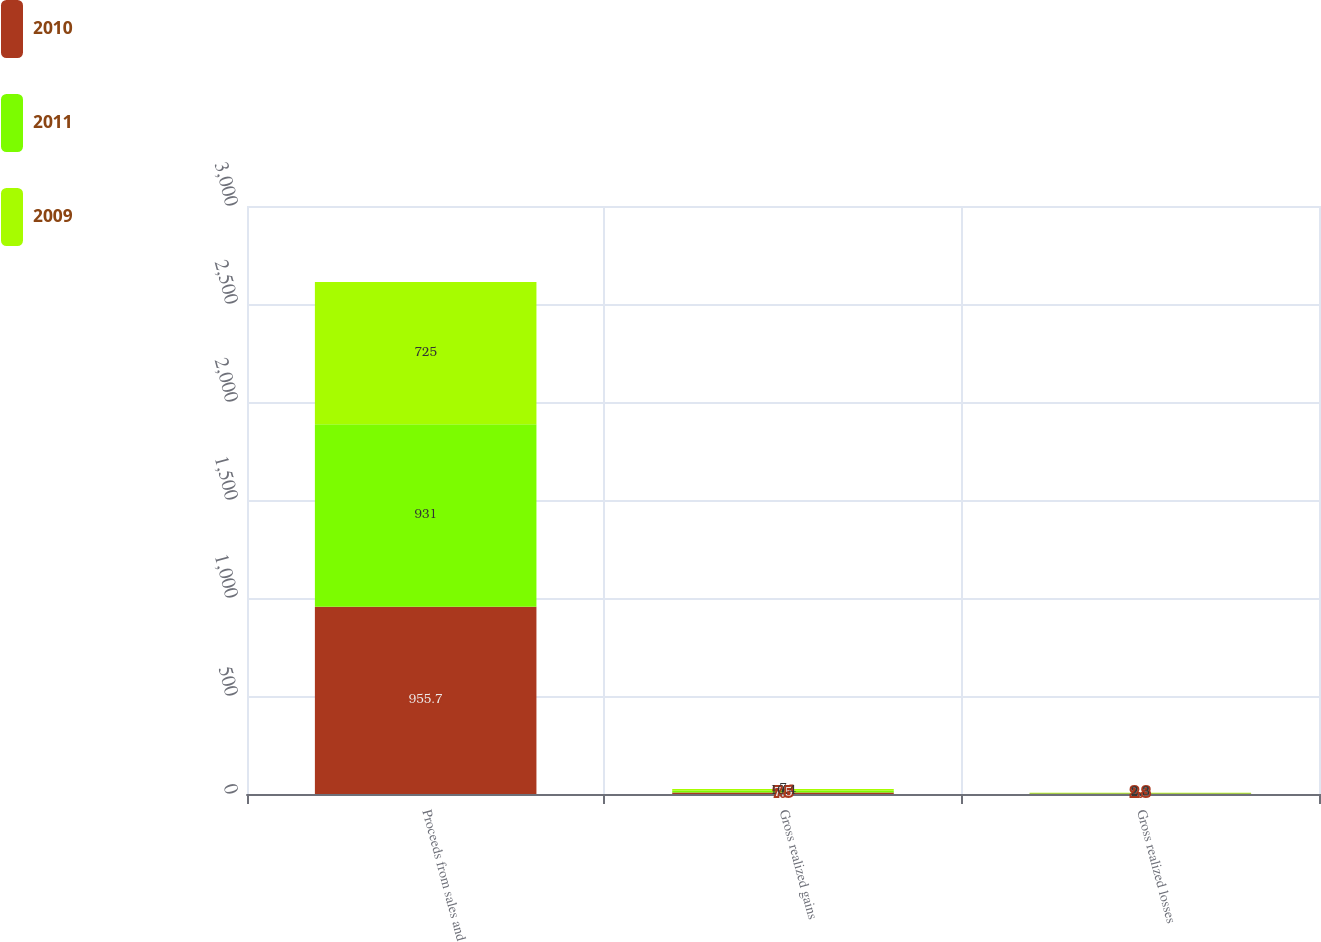Convert chart. <chart><loc_0><loc_0><loc_500><loc_500><stacked_bar_chart><ecel><fcel>Proceeds from sales and<fcel>Gross realized gains<fcel>Gross realized losses<nl><fcel>2010<fcel>955.7<fcel>7.5<fcel>2.3<nl><fcel>2011<fcel>931<fcel>10.4<fcel>2.3<nl><fcel>2009<fcel>725<fcel>7<fcel>2.3<nl></chart> 